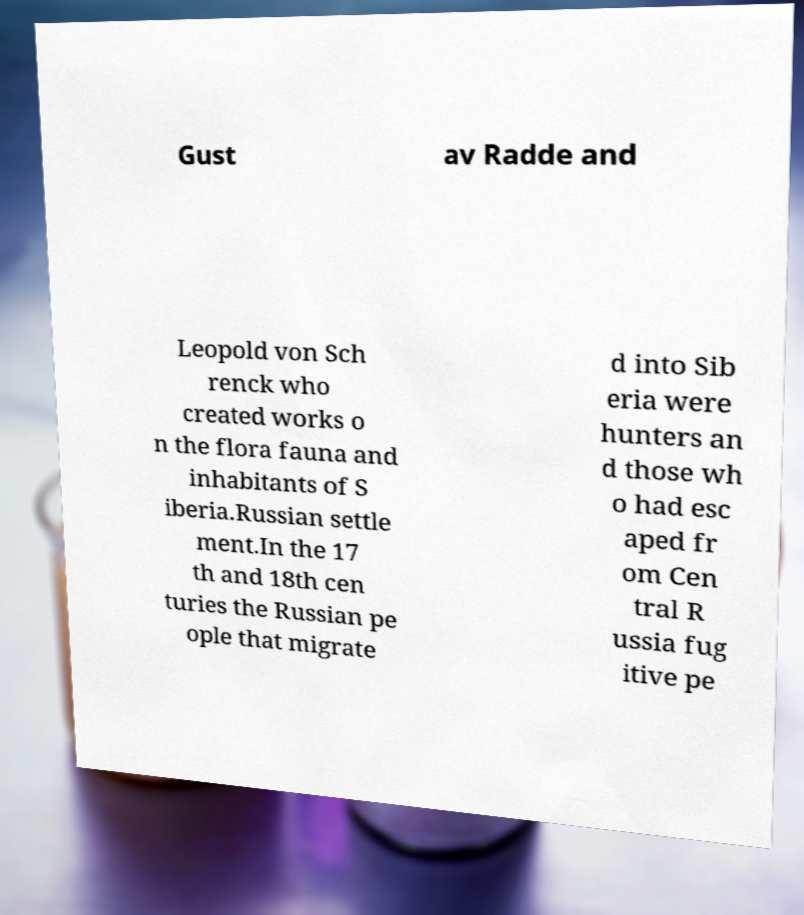Could you assist in decoding the text presented in this image and type it out clearly? Gust av Radde and Leopold von Sch renck who created works o n the flora fauna and inhabitants of S iberia.Russian settle ment.In the 17 th and 18th cen turies the Russian pe ople that migrate d into Sib eria were hunters an d those wh o had esc aped fr om Cen tral R ussia fug itive pe 